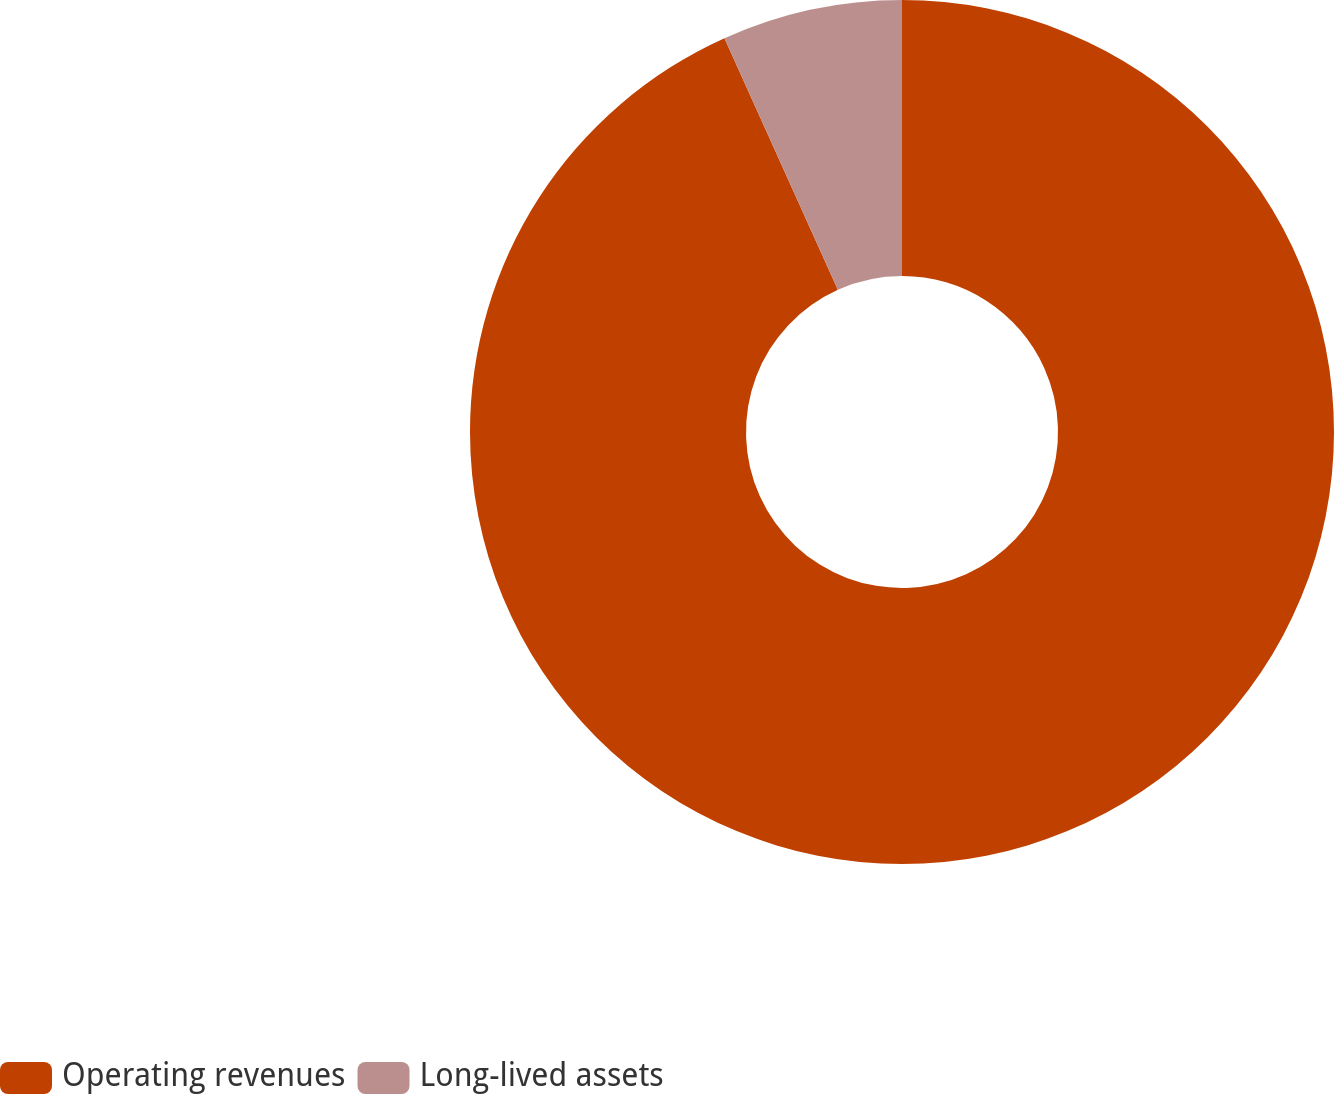Convert chart. <chart><loc_0><loc_0><loc_500><loc_500><pie_chart><fcel>Operating revenues<fcel>Long-lived assets<nl><fcel>93.26%<fcel>6.74%<nl></chart> 